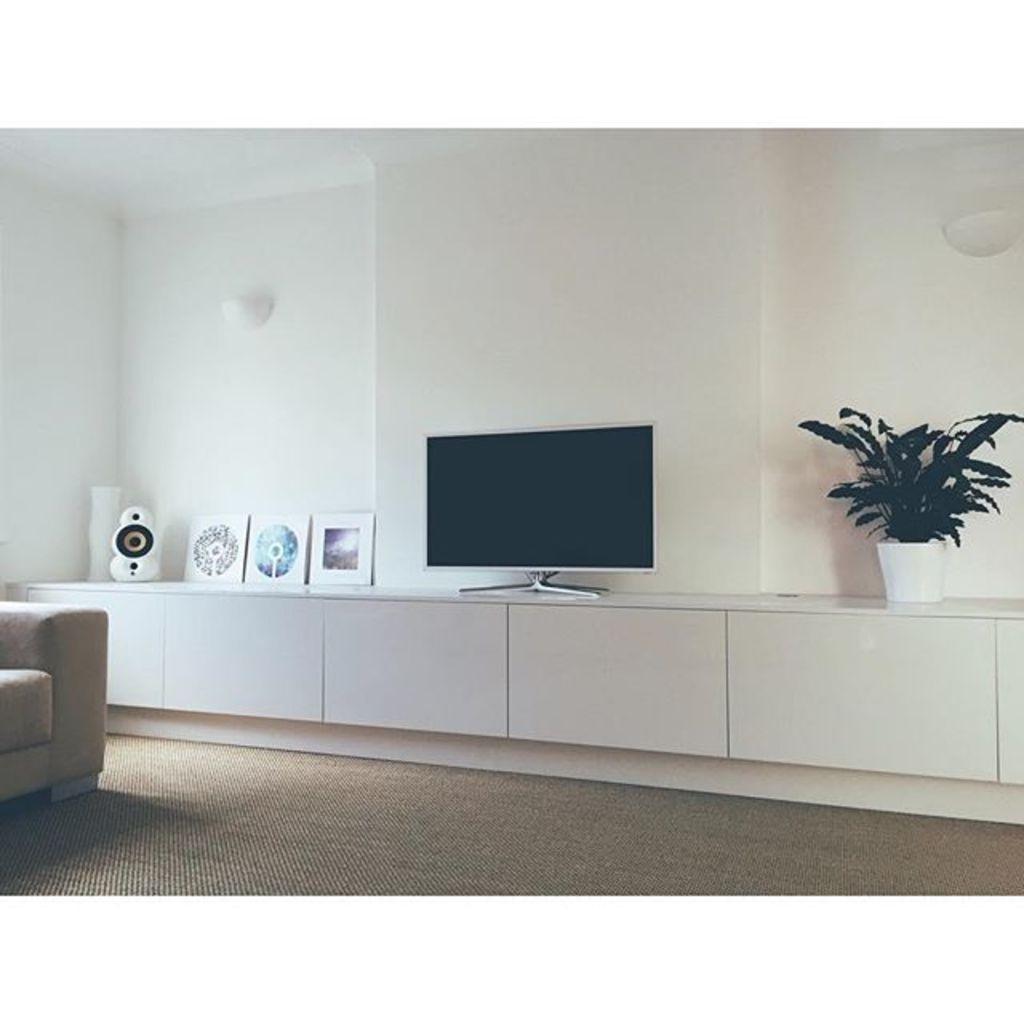Describe this image in one or two sentences. In this image there is a television. Few frames, pot, sound speaker and flower vase are on the shelf. The pot is having a plant. Left side there is a chair on the floor. Background there is a wall having few lights attached to it. 